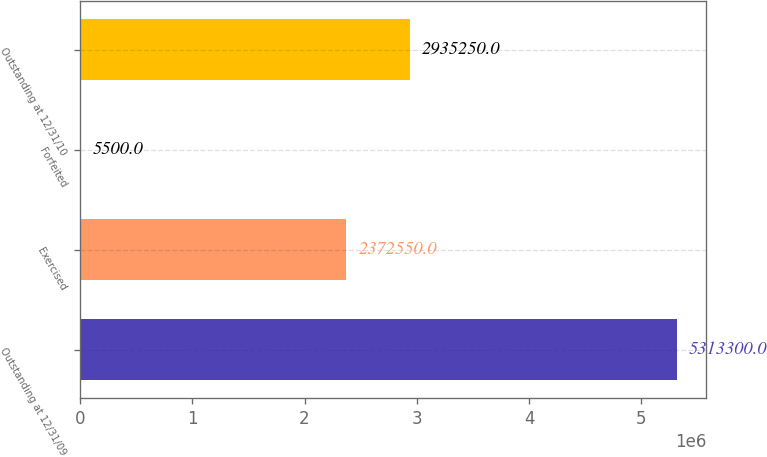Convert chart to OTSL. <chart><loc_0><loc_0><loc_500><loc_500><bar_chart><fcel>Outstanding at 12/31/09<fcel>Exercised<fcel>Forfeited<fcel>Outstanding at 12/31/10<nl><fcel>5.3133e+06<fcel>2.37255e+06<fcel>5500<fcel>2.93525e+06<nl></chart> 